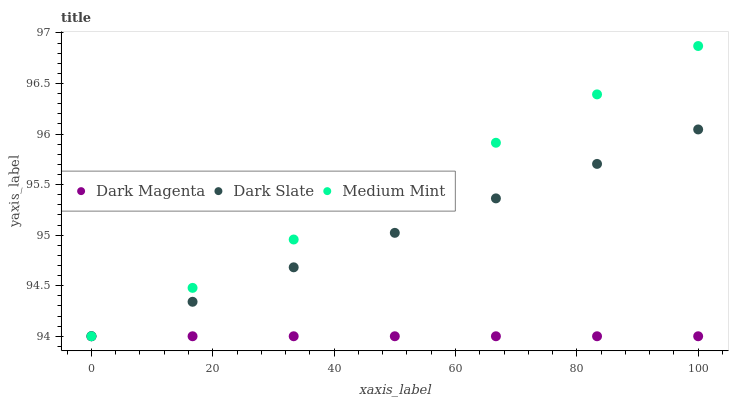Does Dark Magenta have the minimum area under the curve?
Answer yes or no. Yes. Does Medium Mint have the maximum area under the curve?
Answer yes or no. Yes. Does Dark Slate have the minimum area under the curve?
Answer yes or no. No. Does Dark Slate have the maximum area under the curve?
Answer yes or no. No. Is Dark Magenta the smoothest?
Answer yes or no. Yes. Is Medium Mint the roughest?
Answer yes or no. Yes. Is Dark Slate the smoothest?
Answer yes or no. No. Is Dark Slate the roughest?
Answer yes or no. No. Does Medium Mint have the lowest value?
Answer yes or no. Yes. Does Medium Mint have the highest value?
Answer yes or no. Yes. Does Dark Slate have the highest value?
Answer yes or no. No. Does Dark Slate intersect Dark Magenta?
Answer yes or no. Yes. Is Dark Slate less than Dark Magenta?
Answer yes or no. No. Is Dark Slate greater than Dark Magenta?
Answer yes or no. No. 